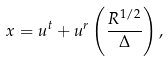<formula> <loc_0><loc_0><loc_500><loc_500>x = u ^ { t } + u ^ { r } \left ( \frac { R ^ { 1 / 2 } } { \Delta } \right ) ,</formula> 